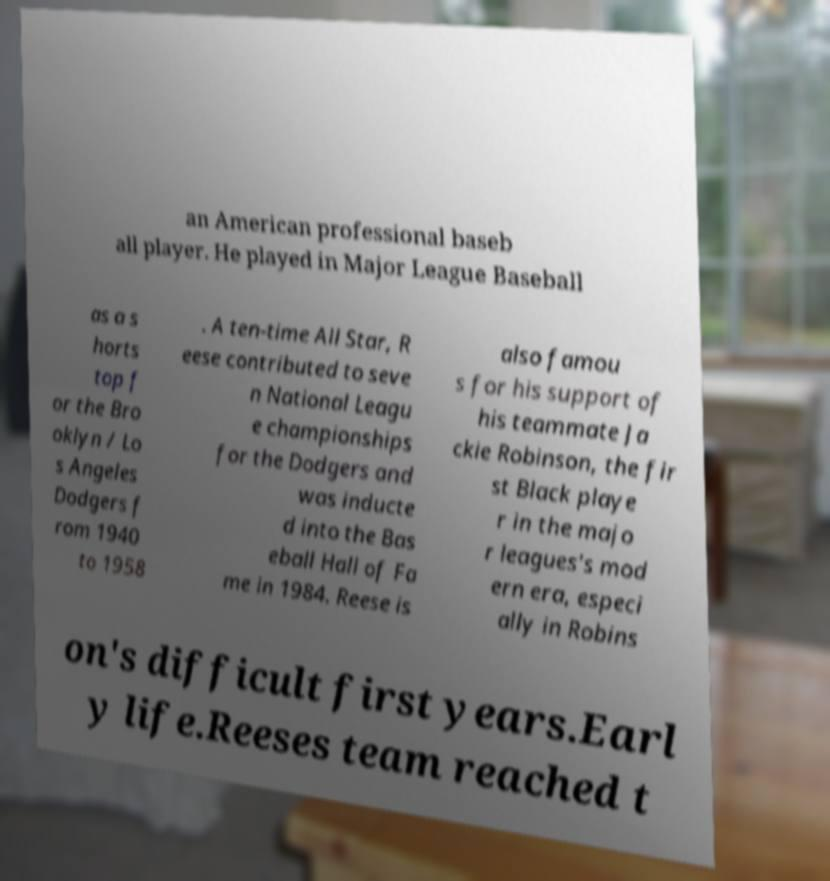I need the written content from this picture converted into text. Can you do that? an American professional baseb all player. He played in Major League Baseball as a s horts top f or the Bro oklyn / Lo s Angeles Dodgers f rom 1940 to 1958 . A ten-time All Star, R eese contributed to seve n National Leagu e championships for the Dodgers and was inducte d into the Bas eball Hall of Fa me in 1984. Reese is also famou s for his support of his teammate Ja ckie Robinson, the fir st Black playe r in the majo r leagues's mod ern era, especi ally in Robins on's difficult first years.Earl y life.Reeses team reached t 